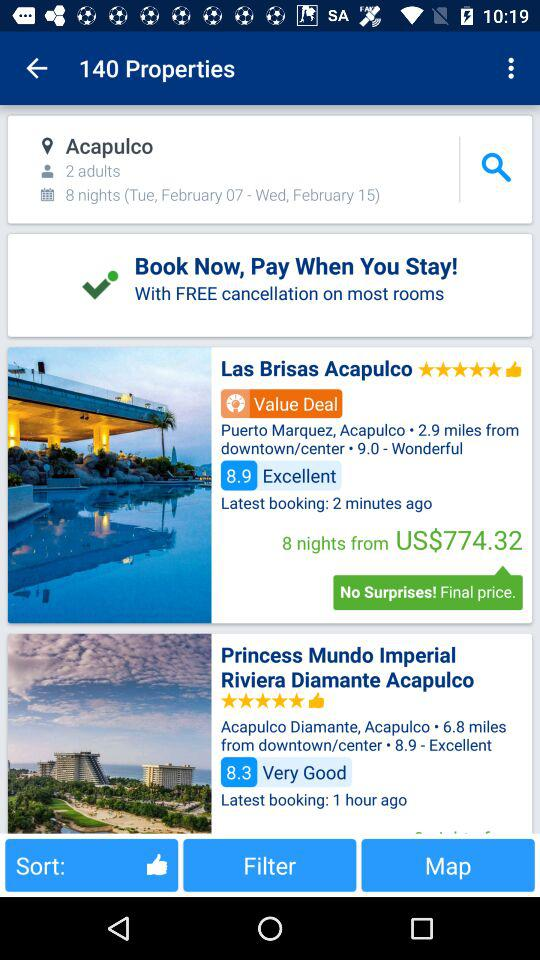How much is the rating for "Las Brisas Acapulco" given by viewers? The rating given by viewers is 5 stars. 